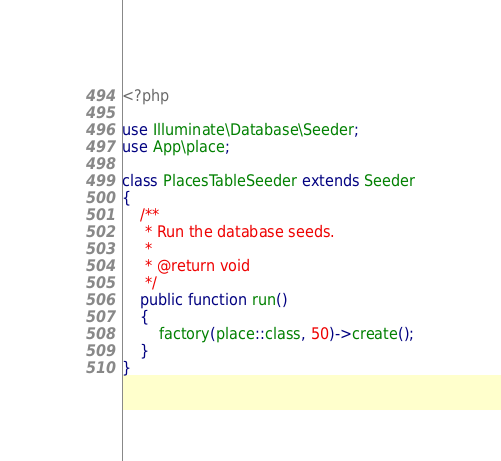Convert code to text. <code><loc_0><loc_0><loc_500><loc_500><_PHP_><?php

use Illuminate\Database\Seeder;
use App\place;

class PlacesTableSeeder extends Seeder
{
    /**
     * Run the database seeds.
     *
     * @return void
     */
    public function run()
    {
        factory(place::class, 50)->create();
    }
}
</code> 